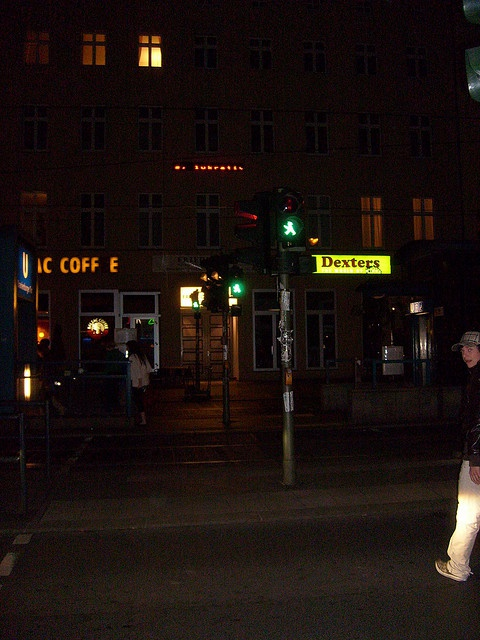Describe the objects in this image and their specific colors. I can see people in black, beige, tan, and gray tones, people in black, maroon, and brown tones, traffic light in black, maroon, brown, and red tones, traffic light in black, darkgreen, white, and green tones, and people in black tones in this image. 